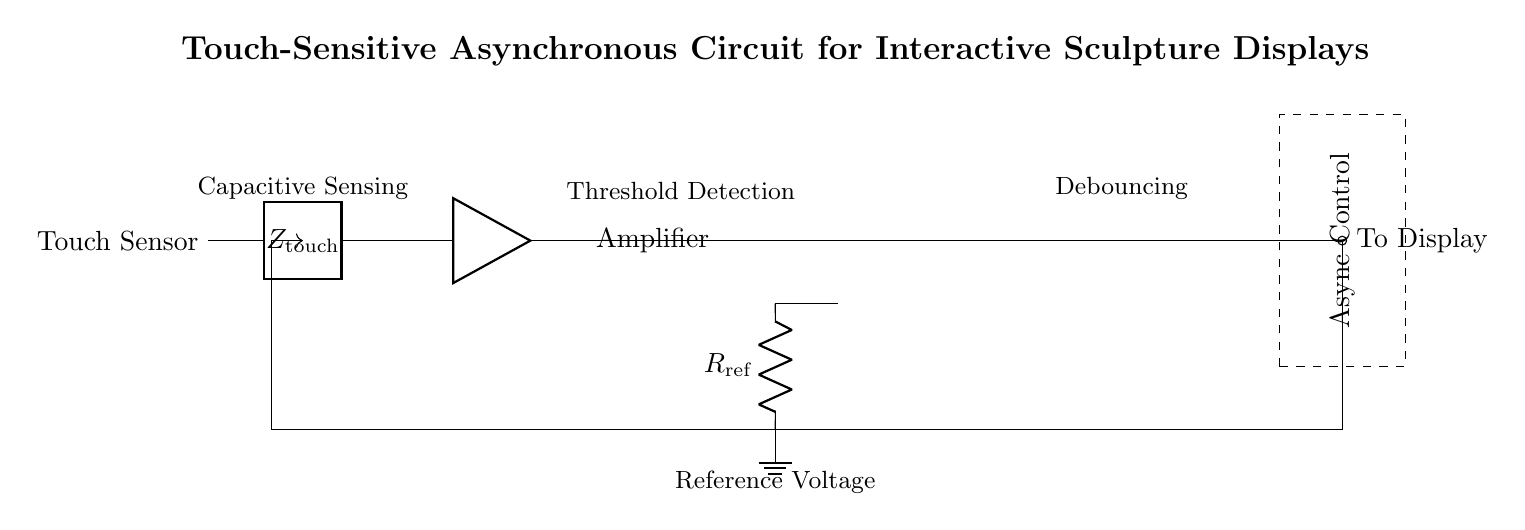What component is used for sensing? The component used for sensing in the circuit is labeled as "Touch Sensor," which is designed to detect touch or capacitance changes.
Answer: Touch Sensor What does the amplifier do in this circuit? The amplifier increases the sensitivity of the touch sensor's output, making it easier for subsequent components to detect the signal.
Answer: Increases sensitivity What is the role of the reference resistor in the comparator? The reference resistor, labeled as "R_ref," sets a threshold level against which the input signal from the amplifier is compared to determine if it exceeds this threshold.
Answer: Sets threshold level What type of logic is used in this circuit? The circuit uses asynchronous control logic, which allows outputs to change independently of a clock signal and based on the input conditions.
Answer: Asynchronous How does the Schmitt Trigger function in this circuit? The Schmitt Trigger provides debouncing for the output signal from the comparator, allowing for stable output despite noisy inputs or rapid changes in state.
Answer: Provides debouncing Which components are involved in feedback within the circuit? The feedback in the circuit involves the output from the asynchronous control logic that loops back to influence the touch sensor inputs and other components.
Answer: Output from control logic What is the significance of the dashed rectangle in the diagram? The dashed rectangle labeled "Async Control" indicates the section of the circuit containing the asynchronous control logic, which manages the output behavior based on input signals.
Answer: Indicates control logic section 